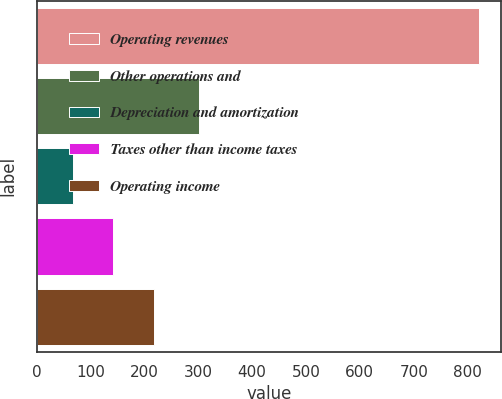<chart> <loc_0><loc_0><loc_500><loc_500><bar_chart><fcel>Operating revenues<fcel>Other operations and<fcel>Depreciation and amortization<fcel>Taxes other than income taxes<fcel>Operating income<nl><fcel>821<fcel>301<fcel>67<fcel>142.4<fcel>217.8<nl></chart> 